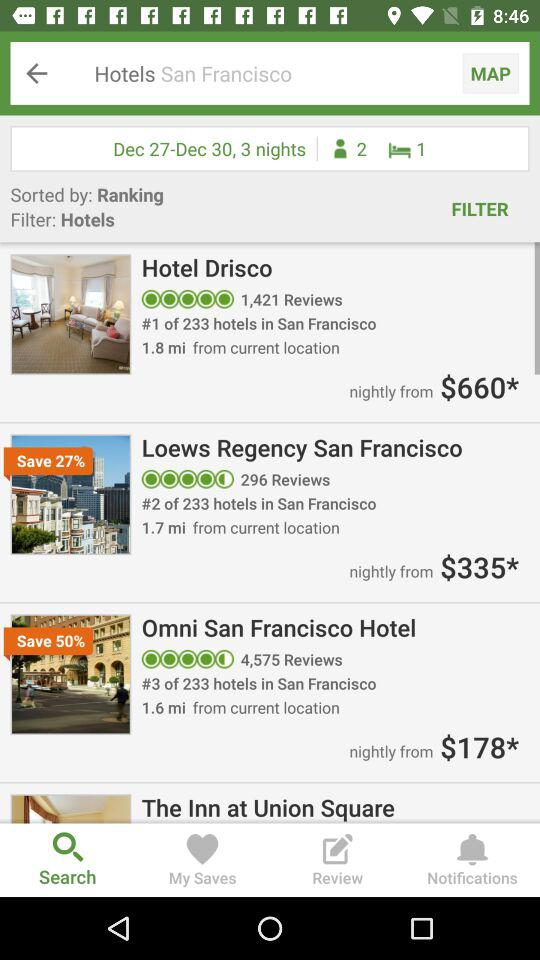What is the application name? The application name is "tripadvisor". 